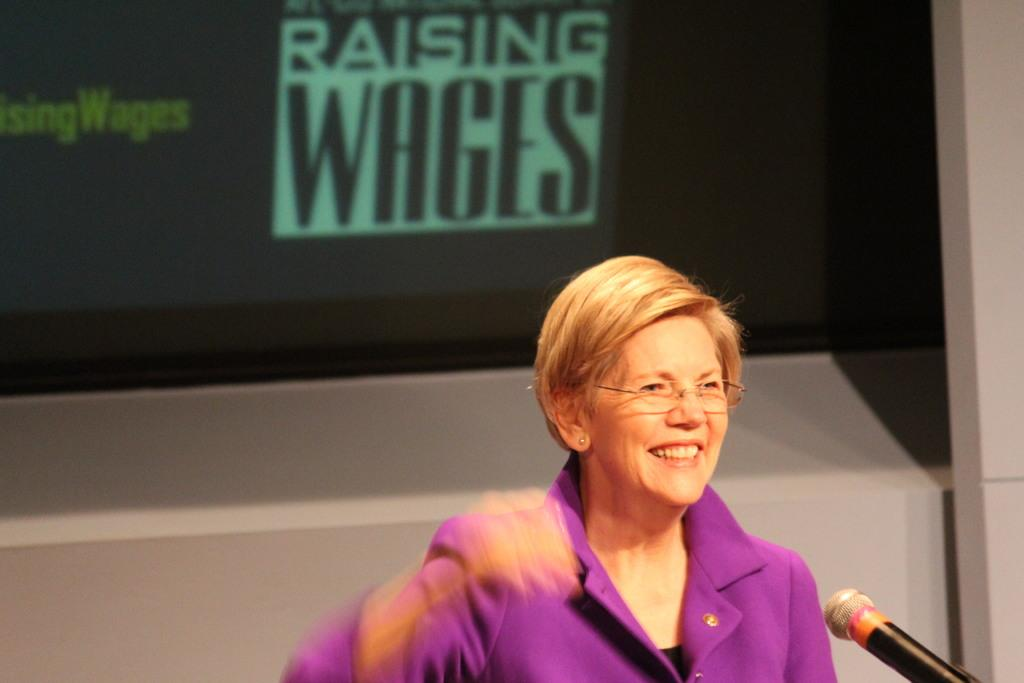Who is present in the image? There is a woman in the image. What is the woman doing in the image? The woman is smiling. What accessories is the woman wearing in the image? The woman is wearing spectacles. What color is the dress the woman is wearing in the image? The woman is wearing a purple color dress. What object can be seen in the image that is typically used for amplifying sound? There is a microphone in the image. What can be seen in the background of the image that represents a symbol or design? There is a logo in the background of the image. What type of animal can be seen walking next to the woman in the image? There is no animal present in the image; it only features a woman, a microphone, and a logo in the background. 